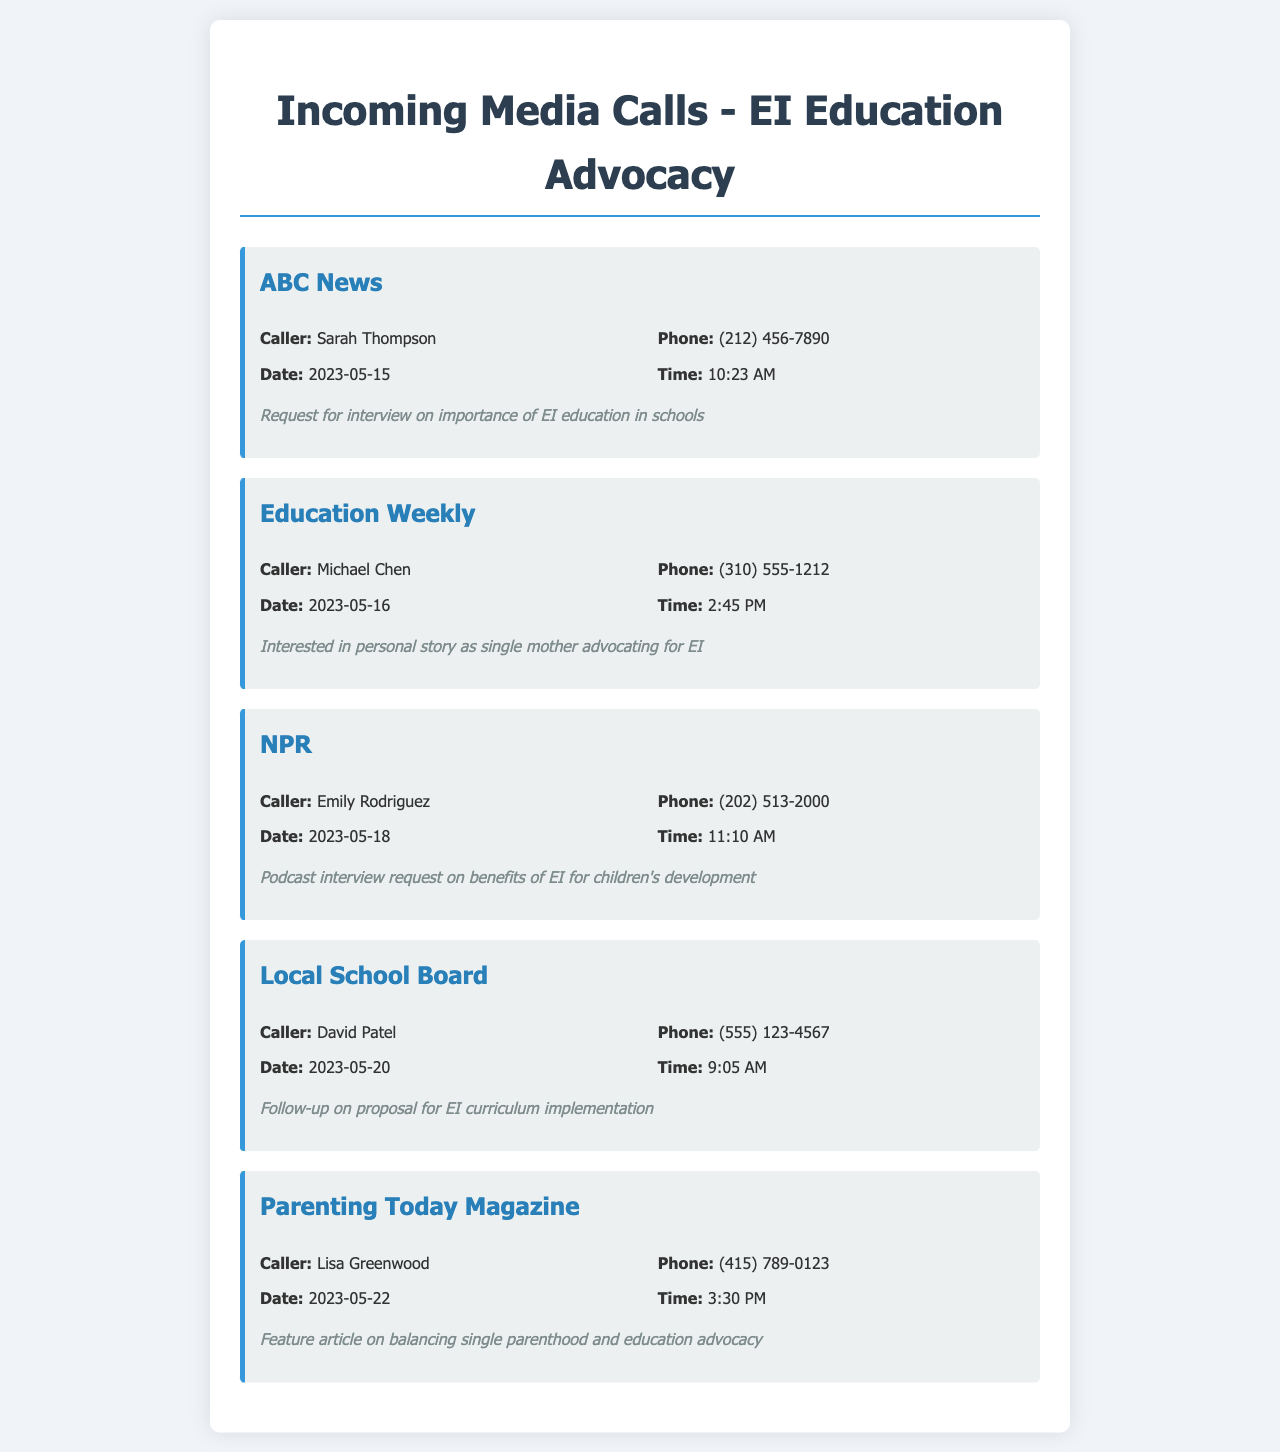What is the name of the caller from ABC News? The name of the caller from ABC News is listed as Sarah Thompson in the records.
Answer: Sarah Thompson On what date did NPR call? The date of the call from NPR is specified in the document as May 18, 2023.
Answer: 2023-05-18 What is the topic of the interview request from Education Weekly? The document mentions that Education Weekly is interested in a personal story related to emotional intelligence education advocacy.
Answer: Personal story How many calls were received in total? By counting the individual call records listed in the document, we find there are five incoming calls.
Answer: 5 What time did the call from Parenting Today Magazine occur? The time of the call from Parenting Today Magazine is noted as 3:30 PM in the records.
Answer: 3:30 PM Which media outlet followed up on a proposal for EI curriculum implementation? The call records indicate that the Local School Board followed up on the EI curriculum proposal.
Answer: Local School Board Who is the caller from the number (310) 555-1212? The document identifies Michael Chen as the caller associated with that phone number.
Answer: Michael Chen What type of content is requested by NPR? NPR requested a podcast interview that discusses the benefits of emotional intelligence for children's development.
Answer: Podcast interview Which single mother is advocating for emotional intelligence education? The document does not provide a name for the single mother specifically, but it refers to a personal story connected to the advocacy effort.
Answer: (not specified) 